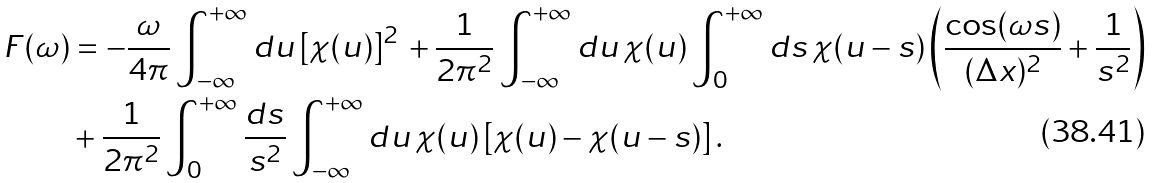Convert formula to latex. <formula><loc_0><loc_0><loc_500><loc_500>F ( \omega ) & = - \frac { \omega } { 4 \pi } \int _ { - \infty } ^ { + \infty } d u \, [ \chi ( u ) ] ^ { 2 } \, + \frac { 1 } { 2 \pi ^ { 2 } } \int _ { - \infty } ^ { + \infty } d u \, \chi ( u ) \int _ { 0 } ^ { + \infty } d s \, \chi ( u - s ) \left ( \frac { \cos ( \omega s ) } { ( \Delta x ) ^ { 2 } } + \frac { 1 } { s ^ { 2 } } \right ) \\ & + \frac { 1 } { 2 \pi ^ { 2 } } \int _ { 0 } ^ { + \infty } \frac { d s } { s ^ { 2 } } \int _ { - \infty } ^ { + \infty } d u \, \chi ( u ) \left [ \chi ( u ) - \chi ( u - s ) \right ] .</formula> 